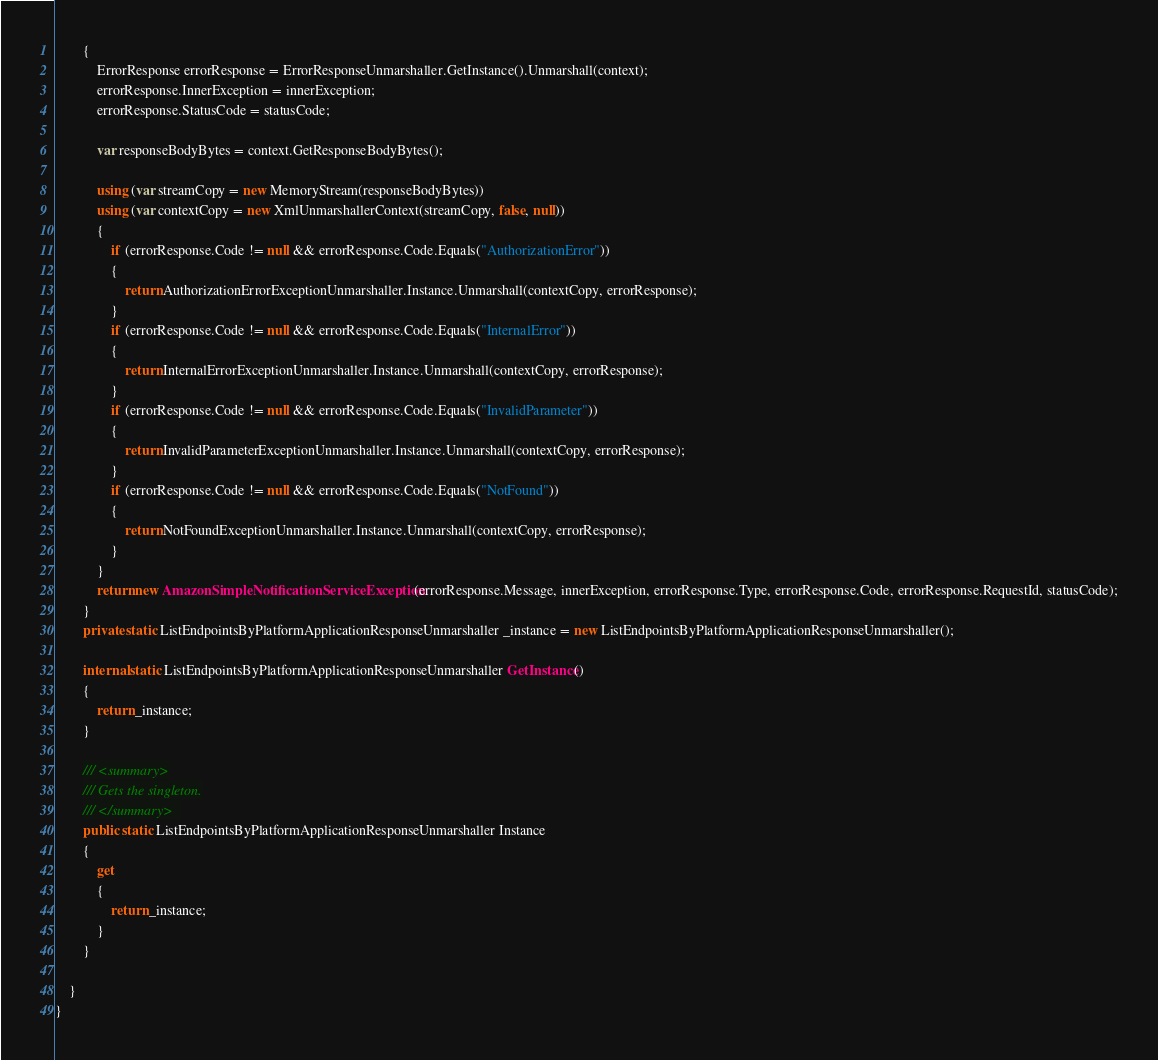Convert code to text. <code><loc_0><loc_0><loc_500><loc_500><_C#_>        {
            ErrorResponse errorResponse = ErrorResponseUnmarshaller.GetInstance().Unmarshall(context);
            errorResponse.InnerException = innerException;
            errorResponse.StatusCode = statusCode;

            var responseBodyBytes = context.GetResponseBodyBytes();

            using (var streamCopy = new MemoryStream(responseBodyBytes))
            using (var contextCopy = new XmlUnmarshallerContext(streamCopy, false, null))
            {
                if (errorResponse.Code != null && errorResponse.Code.Equals("AuthorizationError"))
                {
                    return AuthorizationErrorExceptionUnmarshaller.Instance.Unmarshall(contextCopy, errorResponse);
                }
                if (errorResponse.Code != null && errorResponse.Code.Equals("InternalError"))
                {
                    return InternalErrorExceptionUnmarshaller.Instance.Unmarshall(contextCopy, errorResponse);
                }
                if (errorResponse.Code != null && errorResponse.Code.Equals("InvalidParameter"))
                {
                    return InvalidParameterExceptionUnmarshaller.Instance.Unmarshall(contextCopy, errorResponse);
                }
                if (errorResponse.Code != null && errorResponse.Code.Equals("NotFound"))
                {
                    return NotFoundExceptionUnmarshaller.Instance.Unmarshall(contextCopy, errorResponse);
                }
            }
            return new AmazonSimpleNotificationServiceException(errorResponse.Message, innerException, errorResponse.Type, errorResponse.Code, errorResponse.RequestId, statusCode);
        }
        private static ListEndpointsByPlatformApplicationResponseUnmarshaller _instance = new ListEndpointsByPlatformApplicationResponseUnmarshaller();        

        internal static ListEndpointsByPlatformApplicationResponseUnmarshaller GetInstance()
        {
            return _instance;
        }

        /// <summary>
        /// Gets the singleton.
        /// </summary>  
        public static ListEndpointsByPlatformApplicationResponseUnmarshaller Instance
        {
            get
            {
                return _instance;
            }
        }

    }
}</code> 